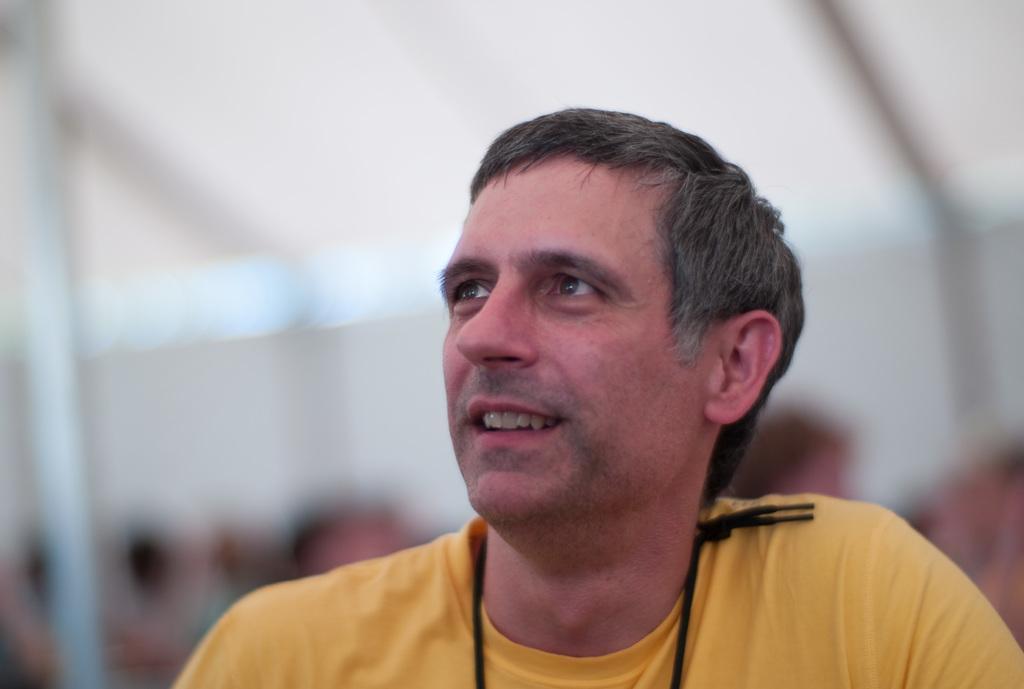Can you describe this image briefly? In this image in front there is a person. Behind him there are a few other people and the background of the image is blur. 